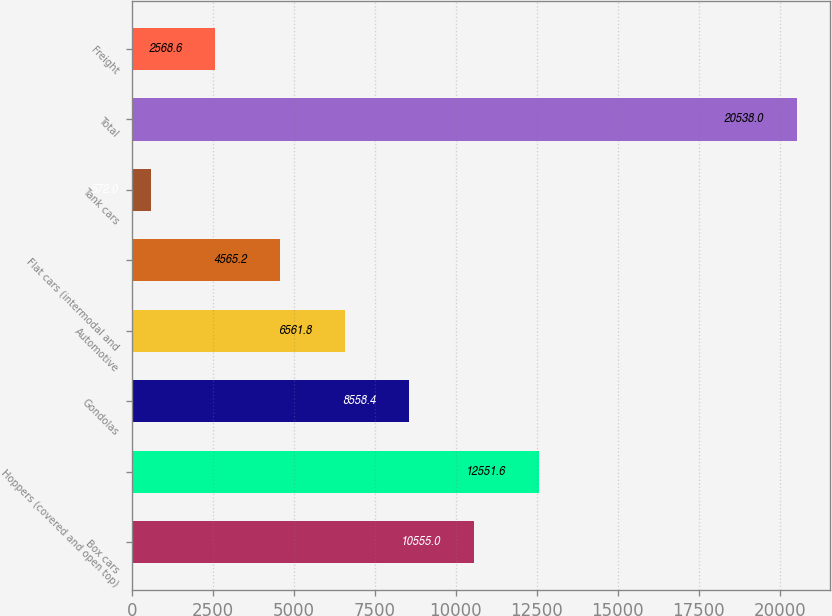Convert chart to OTSL. <chart><loc_0><loc_0><loc_500><loc_500><bar_chart><fcel>Box cars<fcel>Hoppers (covered and open top)<fcel>Gondolas<fcel>Automotive<fcel>Flat cars (intermodal and<fcel>Tank cars<fcel>Total<fcel>Freight<nl><fcel>10555<fcel>12551.6<fcel>8558.4<fcel>6561.8<fcel>4565.2<fcel>572<fcel>20538<fcel>2568.6<nl></chart> 